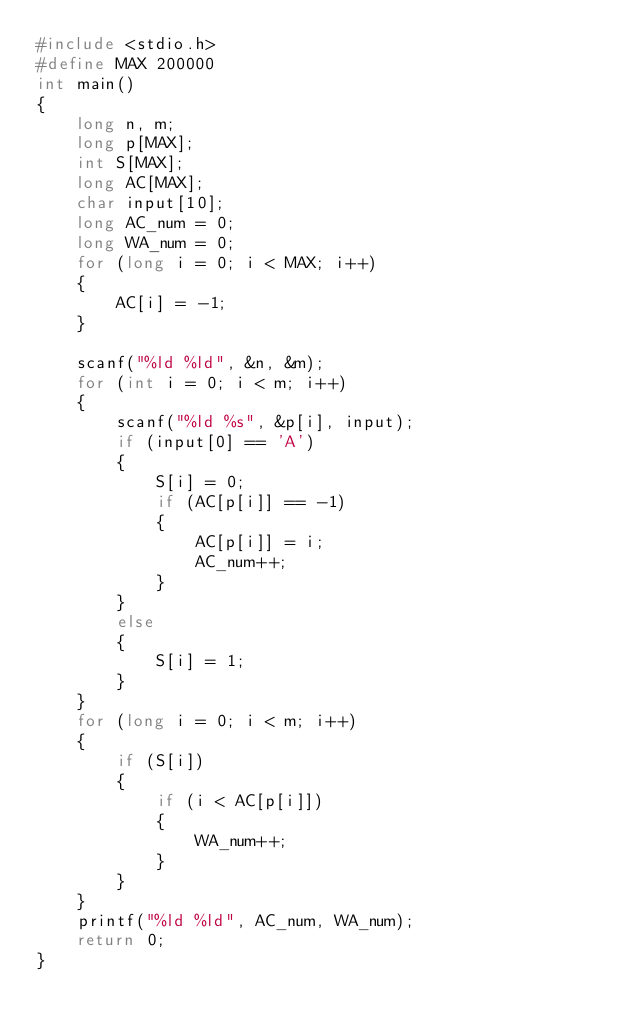Convert code to text. <code><loc_0><loc_0><loc_500><loc_500><_C_>#include <stdio.h>
#define MAX 200000
int main()
{
    long n, m;
    long p[MAX];
    int S[MAX];
    long AC[MAX];
    char input[10];
    long AC_num = 0;
    long WA_num = 0;
    for (long i = 0; i < MAX; i++)
    {
        AC[i] = -1;
    }

    scanf("%ld %ld", &n, &m);
    for (int i = 0; i < m; i++)
    {
        scanf("%ld %s", &p[i], input);
        if (input[0] == 'A')
        {
            S[i] = 0;
            if (AC[p[i]] == -1)
            {
                AC[p[i]] = i;
                AC_num++;
            }
        }
        else
        {
            S[i] = 1;
        }
    }
    for (long i = 0; i < m; i++)
    {
        if (S[i])
        {
            if (i < AC[p[i]])
            {
                WA_num++;
            }
        }
    }
    printf("%ld %ld", AC_num, WA_num);
    return 0;
}</code> 